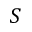Convert formula to latex. <formula><loc_0><loc_0><loc_500><loc_500>S</formula> 